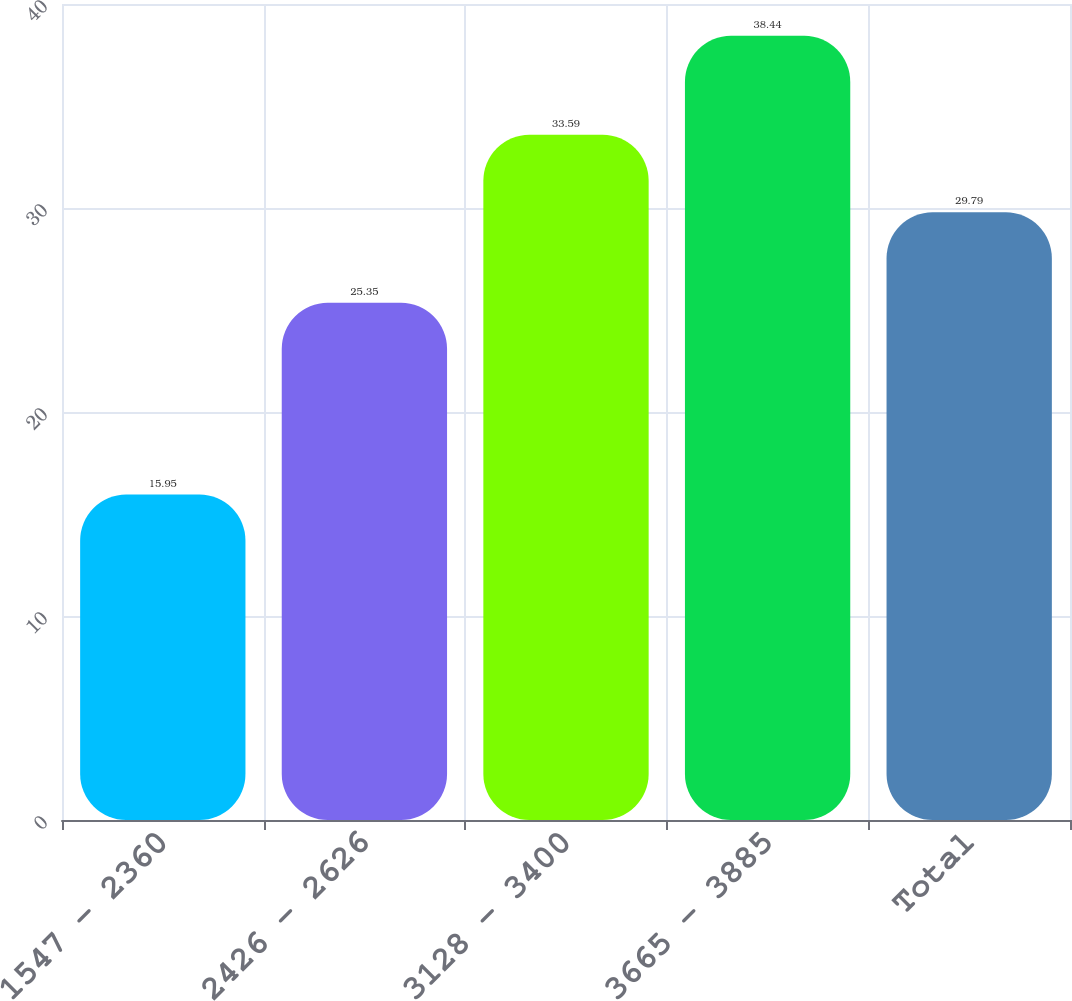Convert chart to OTSL. <chart><loc_0><loc_0><loc_500><loc_500><bar_chart><fcel>1547 - 2360<fcel>2426 - 2626<fcel>3128 - 3400<fcel>3665 - 3885<fcel>Total<nl><fcel>15.95<fcel>25.35<fcel>33.59<fcel>38.44<fcel>29.79<nl></chart> 